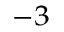<formula> <loc_0><loc_0><loc_500><loc_500>^ { - 3 }</formula> 